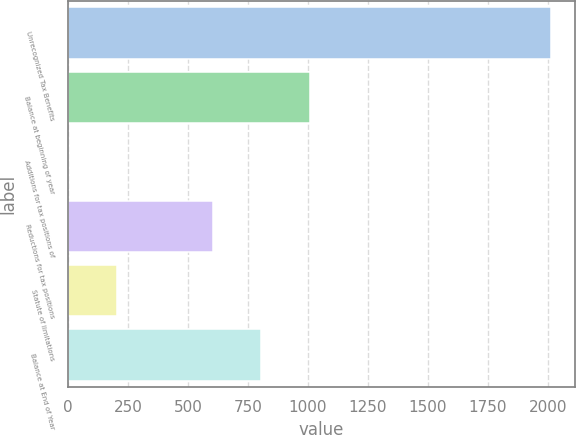Convert chart. <chart><loc_0><loc_0><loc_500><loc_500><bar_chart><fcel>Unrecognized Tax Benefits<fcel>Balance at beginning of year<fcel>Additions for tax positions of<fcel>Reductions for tax positions<fcel>Statute of limitations<fcel>Balance at End of Year<nl><fcel>2012<fcel>1007.15<fcel>2.3<fcel>605.21<fcel>203.27<fcel>806.18<nl></chart> 